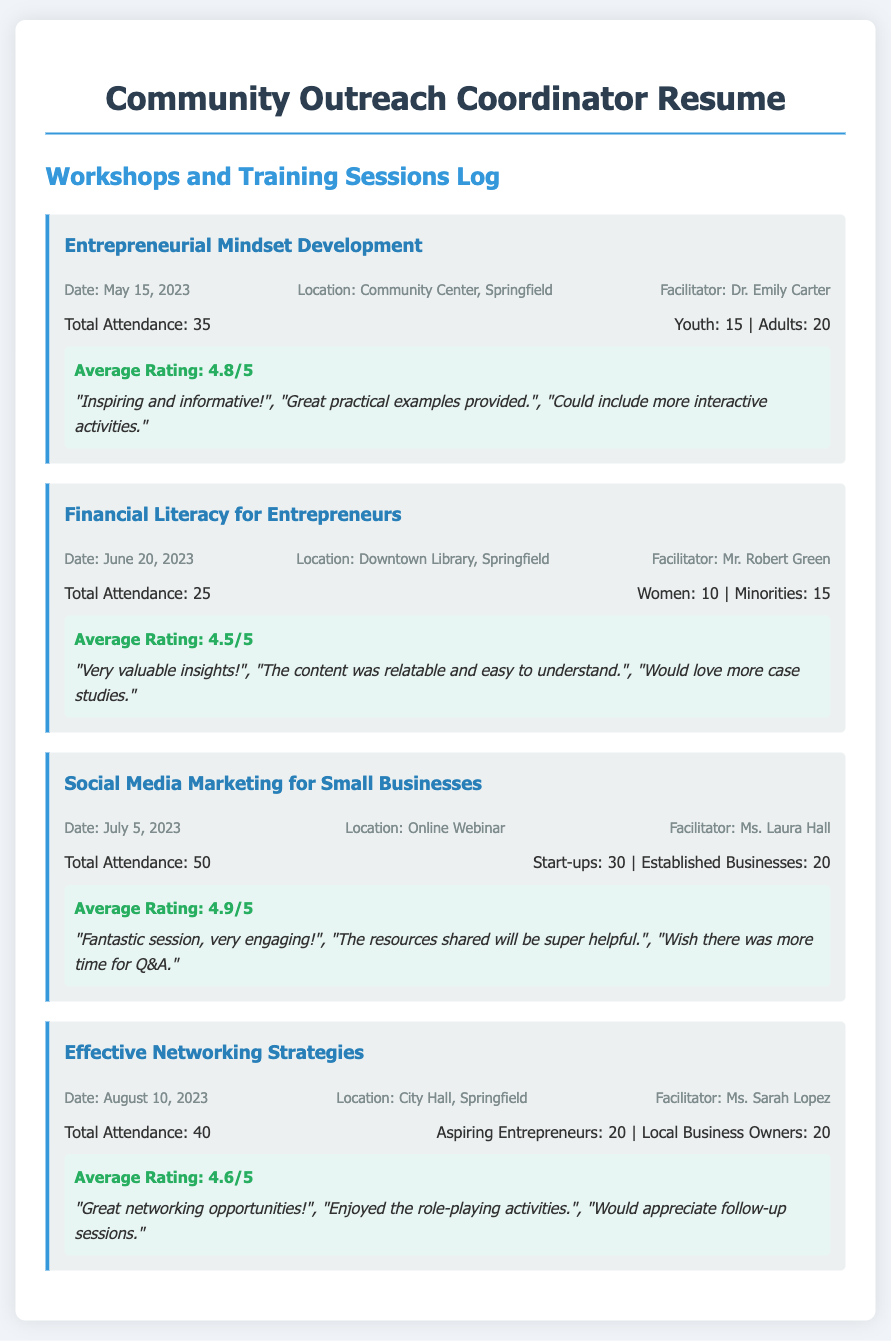What was the average rating of the "Financial Literacy for Entrepreneurs" workshop? The average rating can be found in the feedback section for this workshop, which states 4.5 out of 5.
Answer: 4.5/5 Who facilitated the "Effective Networking Strategies" workshop? The facilitator's name is provided in the workshop details, where it lists Ms. Sarah Lopez.
Answer: Ms. Sarah Lopez What was the total attendance for the "Social Media Marketing for Small Businesses" workshop? The total attendance for this workshop is specified, which is 50.
Answer: 50 When was the "Entrepreneurial Mindset Development" workshop held? The date of the workshop is noted within the workshop details as May 15, 2023.
Answer: May 15, 2023 How many women attended the "Financial Literacy for Entrepreneurs" workshop? The document indicates that 10 women attended this workshop as stated in the attendance section.
Answer: 10 Which workshop had the highest average rating? Comparing the average ratings across workshops, the "Social Media Marketing for Small Businesses" workshop had the highest rating of 4.9 out of 5.
Answer: 4.9/5 What location hosted the "Effective Networking Strategies" workshop? The location is stated in the workshop details, identifying City Hall, Springfield as the venue.
Answer: City Hall, Springfield How many aspiring entrepreneurs attended the "Effective Networking Strategies" workshop? The attendance breakdown shows that 20 aspiring entrepreneurs attended this workshop.
Answer: 20 What feedback was given for the "Social Media Marketing for Small Businesses" workshop? The comments section includes specific feedback like "Fantastic session, very engaging!" and other remarks.
Answer: "Fantastic session, very engaging!" 